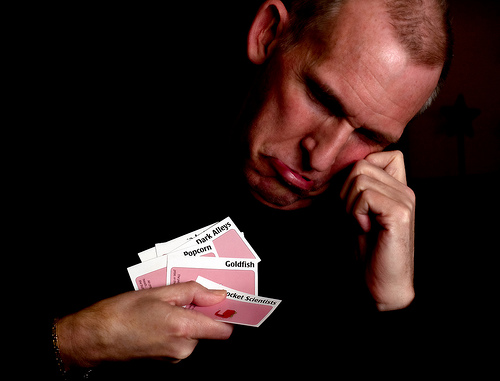<image>
Is there a papers on the man? Yes. Looking at the image, I can see the papers is positioned on top of the man, with the man providing support. 